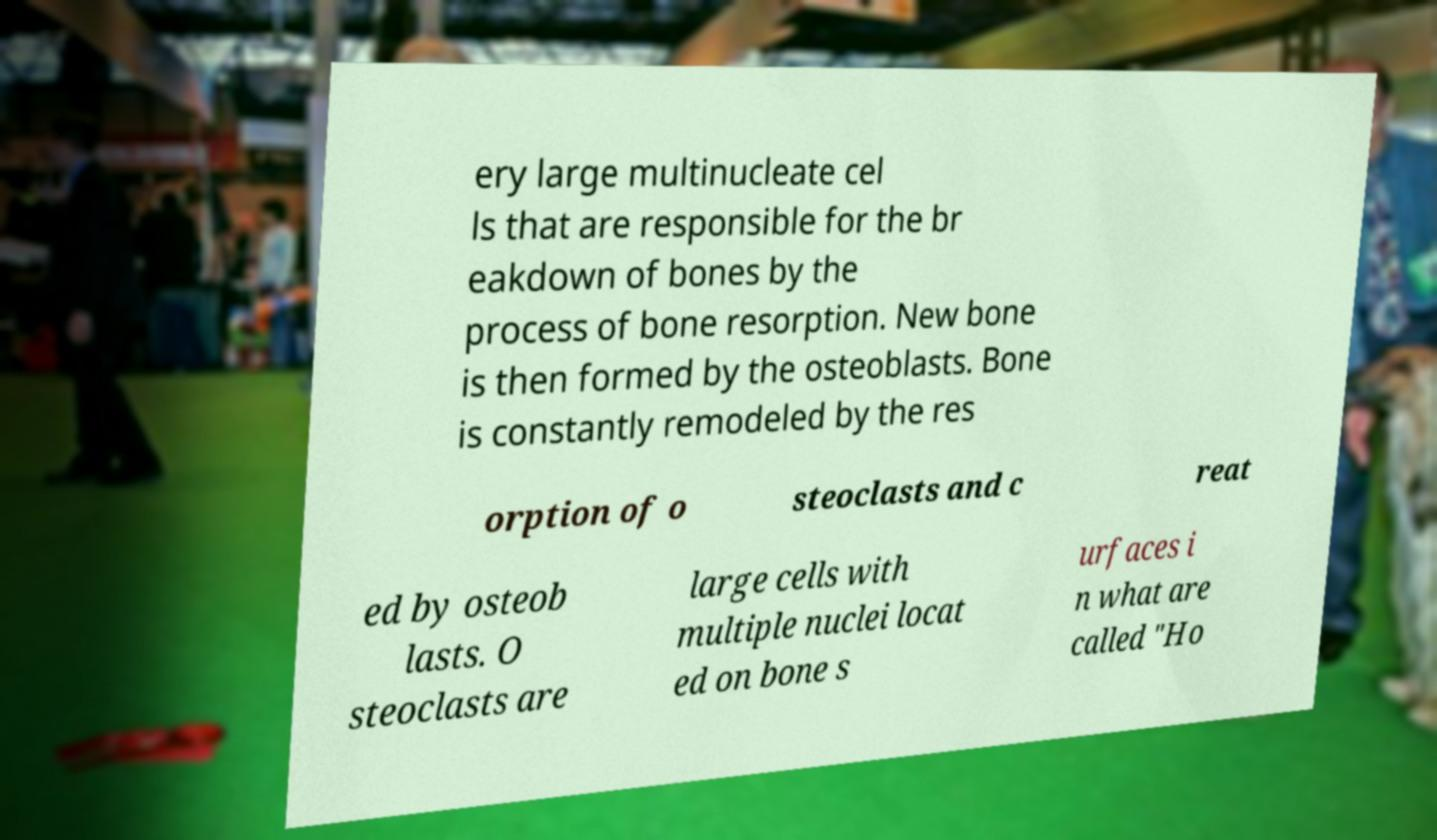Could you extract and type out the text from this image? ery large multinucleate cel ls that are responsible for the br eakdown of bones by the process of bone resorption. New bone is then formed by the osteoblasts. Bone is constantly remodeled by the res orption of o steoclasts and c reat ed by osteob lasts. O steoclasts are large cells with multiple nuclei locat ed on bone s urfaces i n what are called "Ho 